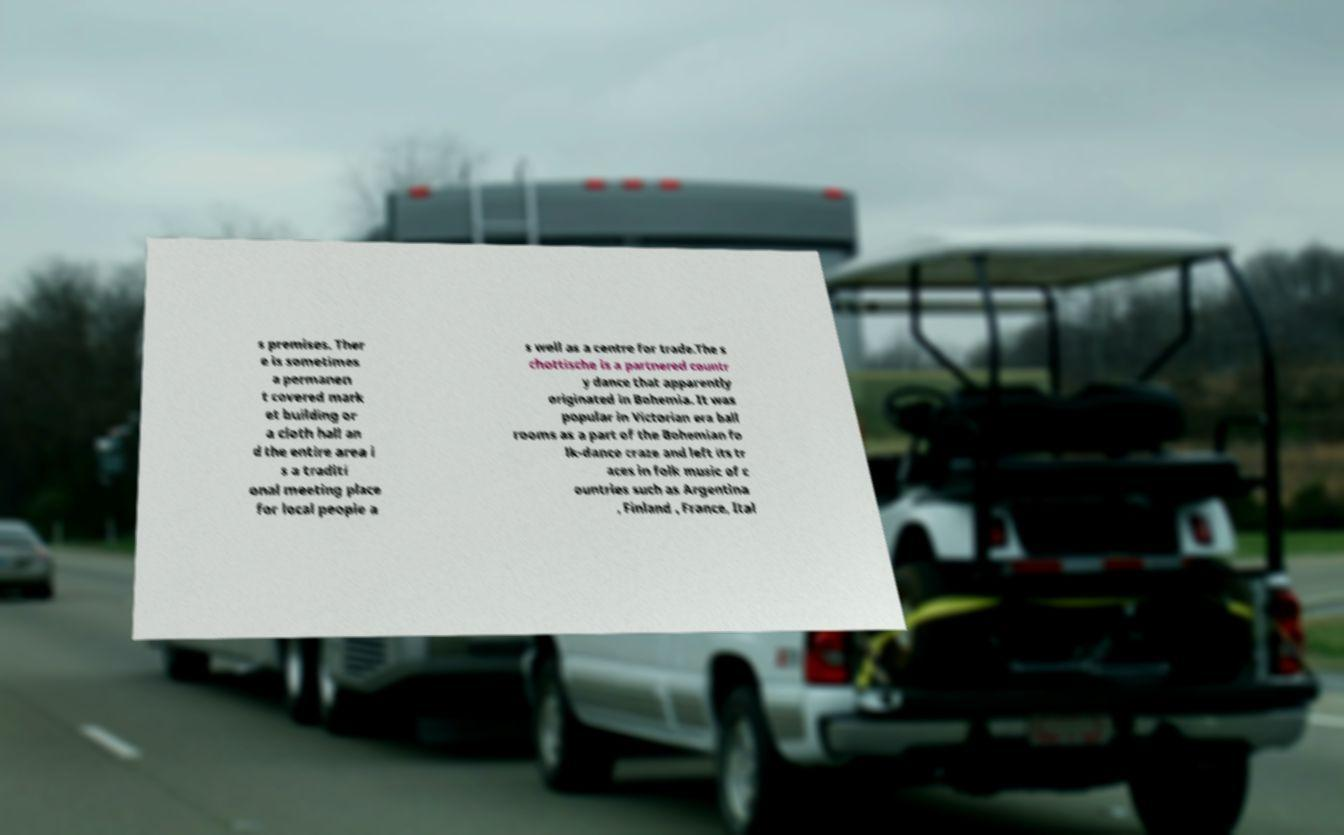Can you accurately transcribe the text from the provided image for me? s premises. Ther e is sometimes a permanen t covered mark et building or a cloth hall an d the entire area i s a traditi onal meeting place for local people a s well as a centre for trade.The s chottische is a partnered countr y dance that apparently originated in Bohemia. It was popular in Victorian era ball rooms as a part of the Bohemian fo lk-dance craze and left its tr aces in folk music of c ountries such as Argentina , Finland , France, Ital 